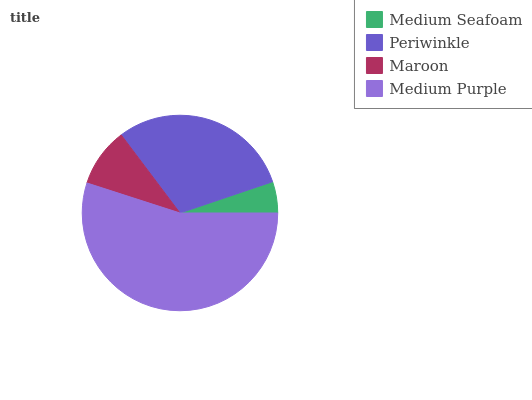Is Medium Seafoam the minimum?
Answer yes or no. Yes. Is Medium Purple the maximum?
Answer yes or no. Yes. Is Periwinkle the minimum?
Answer yes or no. No. Is Periwinkle the maximum?
Answer yes or no. No. Is Periwinkle greater than Medium Seafoam?
Answer yes or no. Yes. Is Medium Seafoam less than Periwinkle?
Answer yes or no. Yes. Is Medium Seafoam greater than Periwinkle?
Answer yes or no. No. Is Periwinkle less than Medium Seafoam?
Answer yes or no. No. Is Periwinkle the high median?
Answer yes or no. Yes. Is Maroon the low median?
Answer yes or no. Yes. Is Medium Seafoam the high median?
Answer yes or no. No. Is Medium Seafoam the low median?
Answer yes or no. No. 